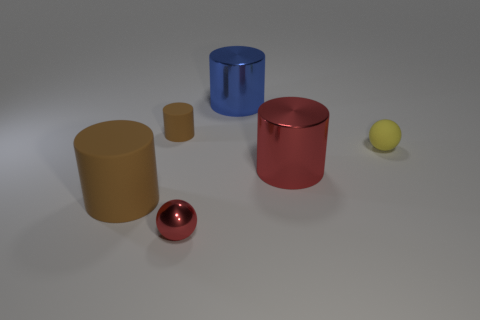What is the color of the object that is both in front of the small matte cylinder and on the left side of the tiny red sphere?
Offer a terse response. Brown. How many other things are the same color as the big matte cylinder?
Provide a succinct answer. 1. There is a big object that is left of the tiny object in front of the red metallic object that is behind the small red metallic sphere; what is it made of?
Keep it short and to the point. Rubber. How many blocks are small purple matte objects or tiny red shiny objects?
Your answer should be very brief. 0. Are there any other things that have the same size as the metal sphere?
Your response must be concise. Yes. How many tiny red things are behind the brown rubber object that is in front of the brown matte thing behind the large rubber cylinder?
Give a very brief answer. 0. Is the shape of the large red shiny thing the same as the big blue object?
Provide a short and direct response. Yes. Does the big blue cylinder that is left of the yellow rubber thing have the same material as the brown thing to the right of the large rubber thing?
Provide a succinct answer. No. What number of things are big things that are in front of the red metallic cylinder or big metallic objects that are to the right of the big blue cylinder?
Offer a very short reply. 2. Is there anything else that is the same shape as the tiny shiny thing?
Give a very brief answer. Yes. 